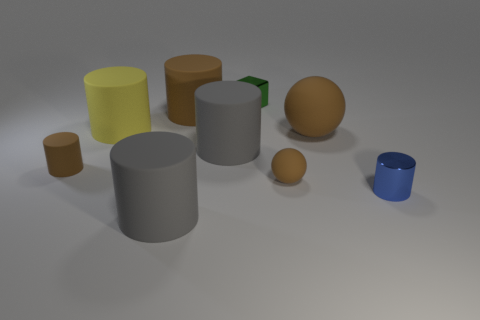Are there any other things that are the same shape as the green shiny thing?
Offer a very short reply. No. How many large objects are either gray things or gray rubber cubes?
Offer a terse response. 2. Is there a big purple object?
Make the answer very short. No. What is the size of the yellow thing that is the same material as the big brown sphere?
Make the answer very short. Large. Is the material of the blue cylinder the same as the small brown cylinder?
Your response must be concise. No. What number of other things are the same material as the blue object?
Keep it short and to the point. 1. How many matte objects are right of the green thing and in front of the tiny brown matte cylinder?
Make the answer very short. 1. What is the color of the block?
Your answer should be compact. Green. What is the material of the yellow thing that is the same shape as the blue object?
Provide a succinct answer. Rubber. Do the tiny rubber cylinder and the large rubber ball have the same color?
Your answer should be compact. Yes. 